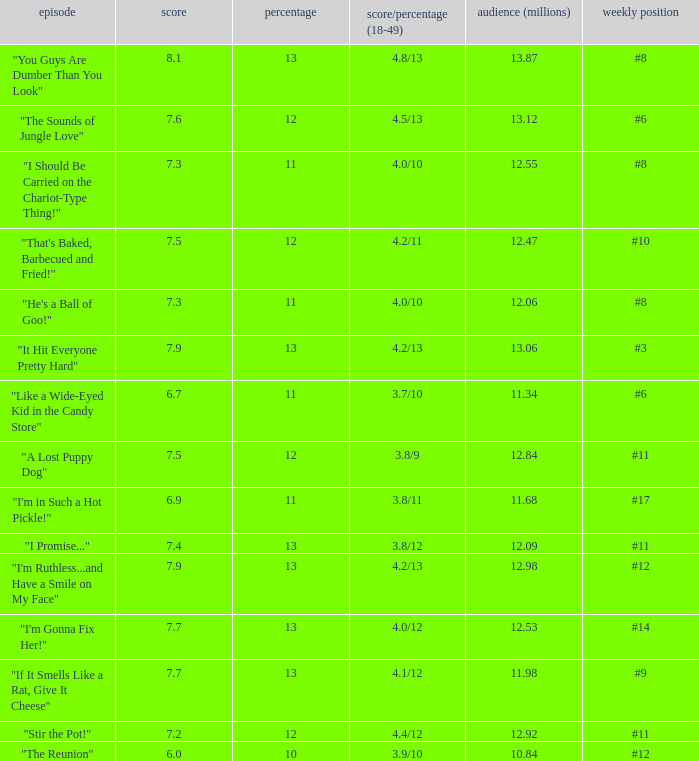What is the average rating for "a lost puppy dog"? 7.5. 